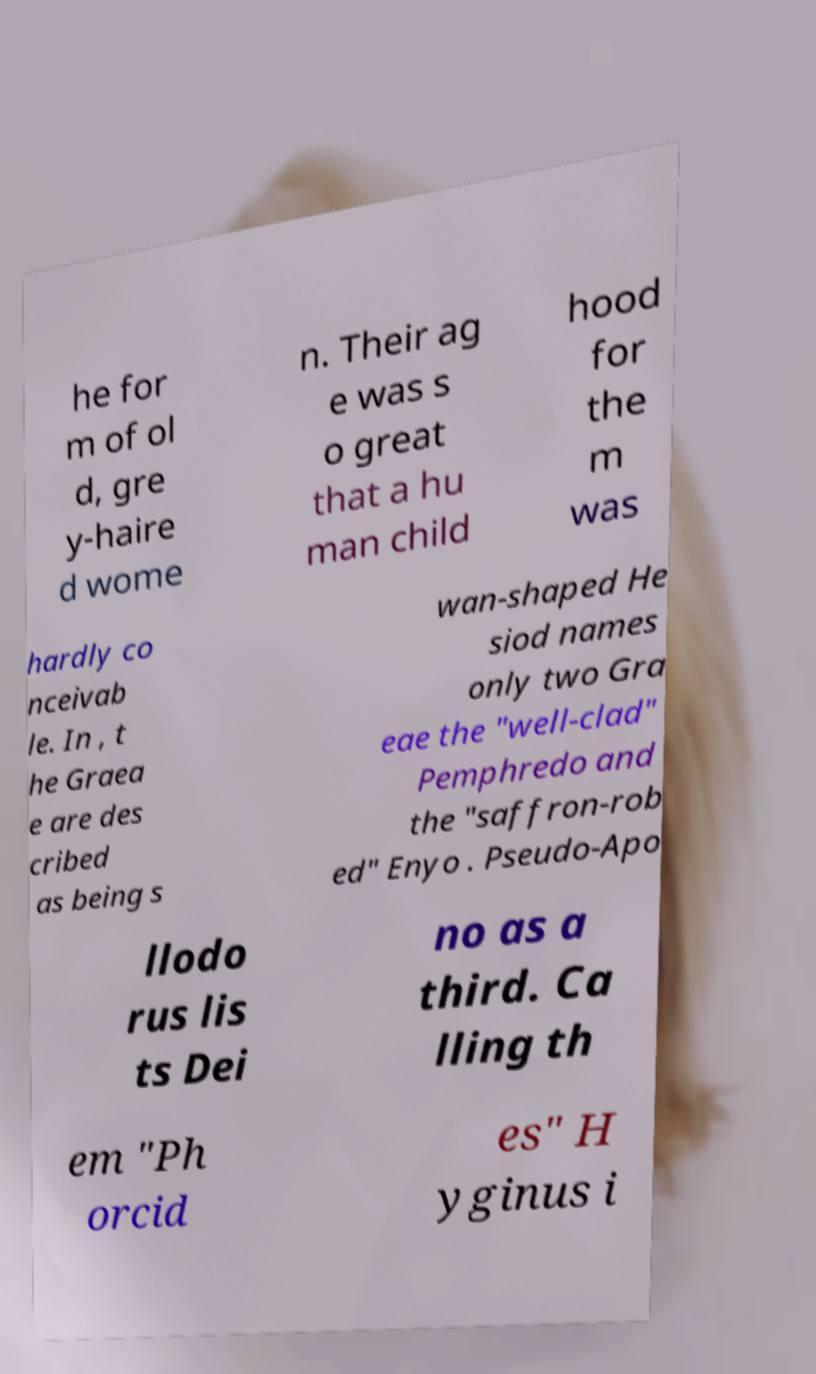Can you accurately transcribe the text from the provided image for me? he for m of ol d, gre y-haire d wome n. Their ag e was s o great that a hu man child hood for the m was hardly co nceivab le. In , t he Graea e are des cribed as being s wan-shaped He siod names only two Gra eae the "well-clad" Pemphredo and the "saffron-rob ed" Enyo . Pseudo-Apo llodo rus lis ts Dei no as a third. Ca lling th em "Ph orcid es" H yginus i 